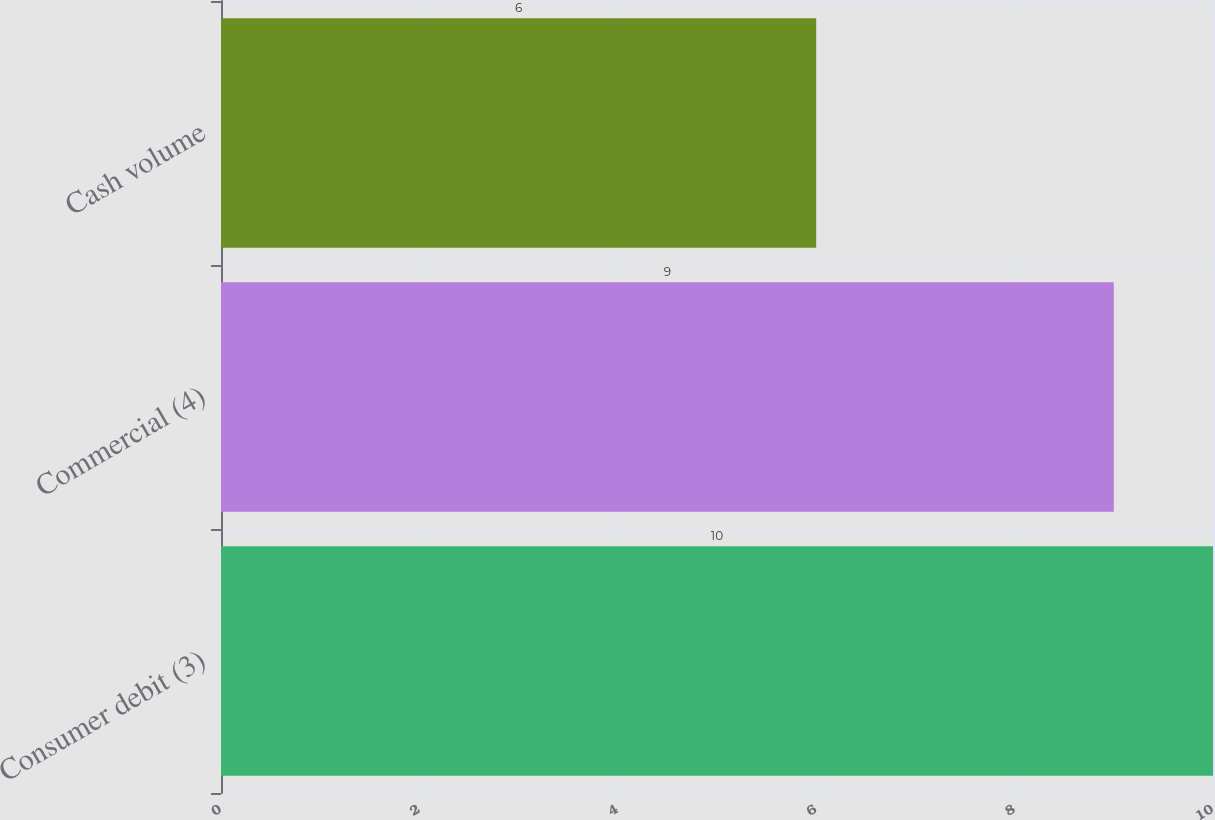Convert chart. <chart><loc_0><loc_0><loc_500><loc_500><bar_chart><fcel>Consumer debit (3)<fcel>Commercial (4)<fcel>Cash volume<nl><fcel>10<fcel>9<fcel>6<nl></chart> 